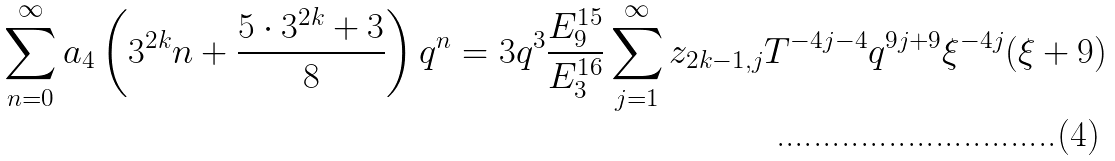<formula> <loc_0><loc_0><loc_500><loc_500>\sum _ { n = 0 } ^ { \infty } a _ { 4 } \left ( 3 ^ { 2 k } n + \frac { 5 \cdot 3 ^ { 2 k } + 3 } { 8 } \right ) q ^ { n } = 3 q ^ { 3 } \frac { E _ { 9 } ^ { 1 5 } } { E _ { 3 } ^ { 1 6 } } \sum _ { j = 1 } ^ { \infty } z _ { 2 k - 1 , j } T ^ { - 4 j - 4 } q ^ { 9 j + 9 } \xi ^ { - 4 j } ( \xi + 9 )</formula> 